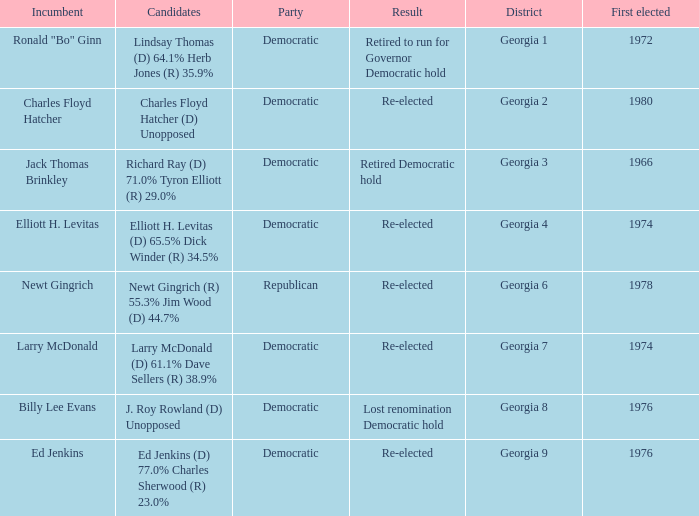Name the districk for larry mcdonald Georgia 7. 